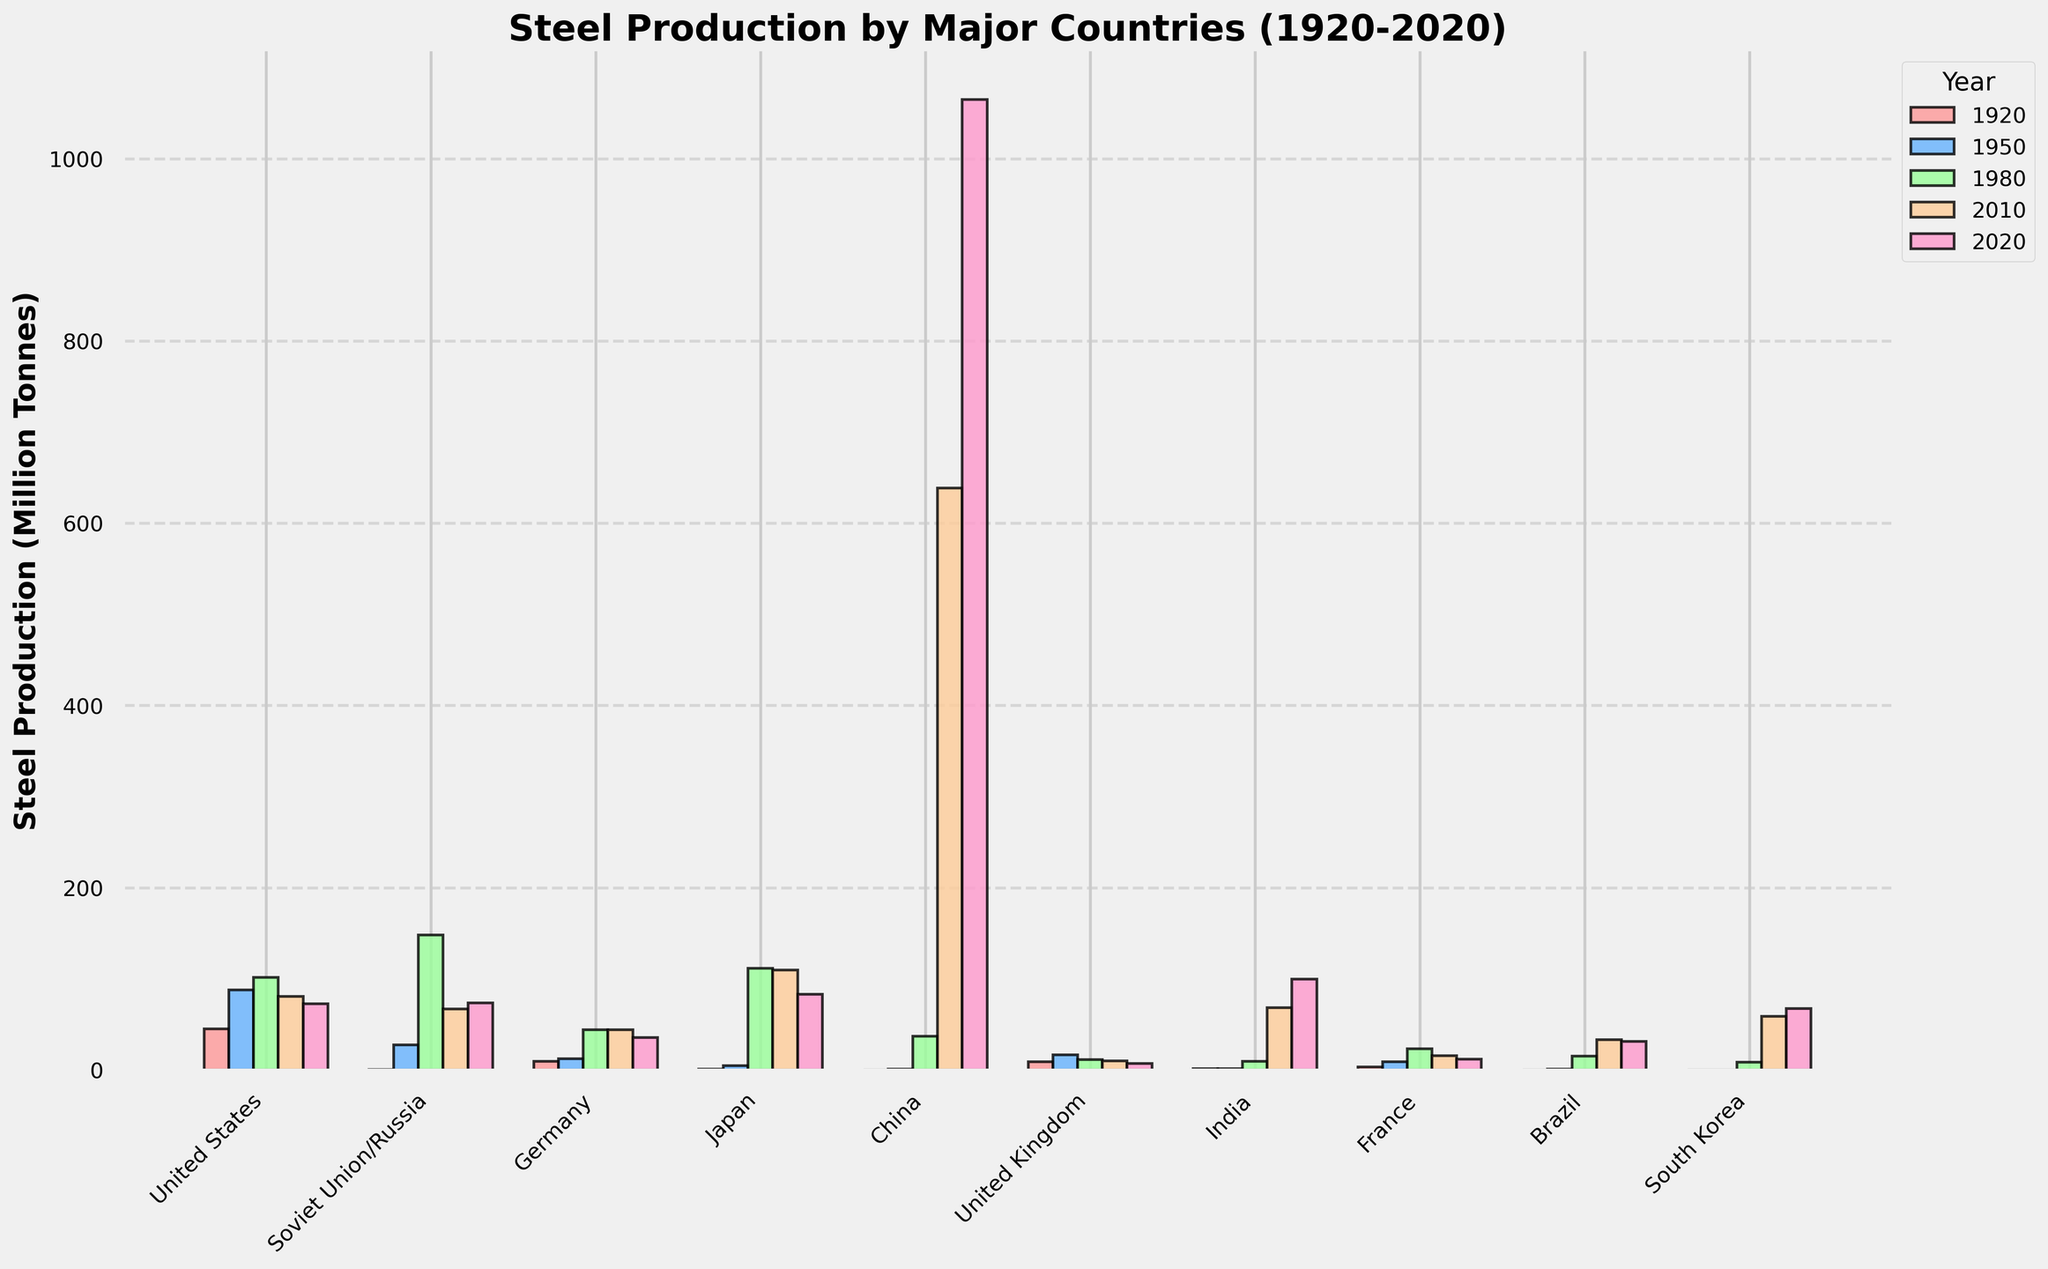What's the overall trend in China's steel production from 1920 to 2020? China’s steel production has seen a massive increase over the century. In 1920, it was nearly negligible at 0.1 million tonnes, then minimally increased to 0.6 million tonnes by 1950. There was a noticeable rise by 1980 at 37.1 million tonnes, followed by a significant spike in 2010 at 638.7 million tonnes, and then further to 1064.8 million tonnes in 2020.
Answer: Significant upward trend Which country had the highest steel production in 1980? Observing the figure, Japan's bar for 1980 is the tallest among all for that year, indicating the highest steel production.
Answer: Japan By how much did steel production in the United States decrease from 1980 to 2020? In 1980, the United States produced 101.5 million tonnes, which decreased to 72.7 million tonnes in 2020. The decrease is calculated as 101.5 - 72.7 = 28.8 million tonnes
Answer: 28.8 million tonnes Which two countries had very close steel production figures in 2020? Looking at the bars for 2020, the steel production figures of the United States and Russia are quite close. The United States produced about 72.7 million tonnes, and Russia produced about 73.4 million tonnes.
Answer: United States and Russia What was the lowest steel production value in 1920 and which country did it belong to? Comparing the bars for each country in 1920, the Soviet Union/Russia had the lowest production at 0.2 million tonnes.
Answer: Soviet Union/Russia How does Germany's steel production in 2020 compare to its 1980 production? Germany's steel production in 1980 was 43.8 million tonnes, and by 2020, it dropped to 35.7 million tonnes. Therefore, the 2020 production is lower than the 1980 figure.
Answer: Lower in 2020 Which country shows the most dramatic rise in production from 1980 to 2020? By inspecting the bars from 1980 to 2020, China's bars show the most significant rise, from 37.1 million tonnes in 1980 to 1064.8 million tonnes in 2020.
Answer: China What is the difference in steel production between India and South Korea in 2010? In 2010, India's production was 68.3 million tonnes and South Korea's was 58.9 million tonnes. The difference is calculated as 68.3 - 58.9 = 9.4 million tonnes.
Answer: 9.4 million tonnes Compare the steel production in Brazil in 1920 and 2020. Is there a significant change? Brazil produced virtually no steel in 1920 (0.0 million tonnes) and increased to 31.0 million tonnes by 2020, indicating a significant increase.
Answer: Significant increase 